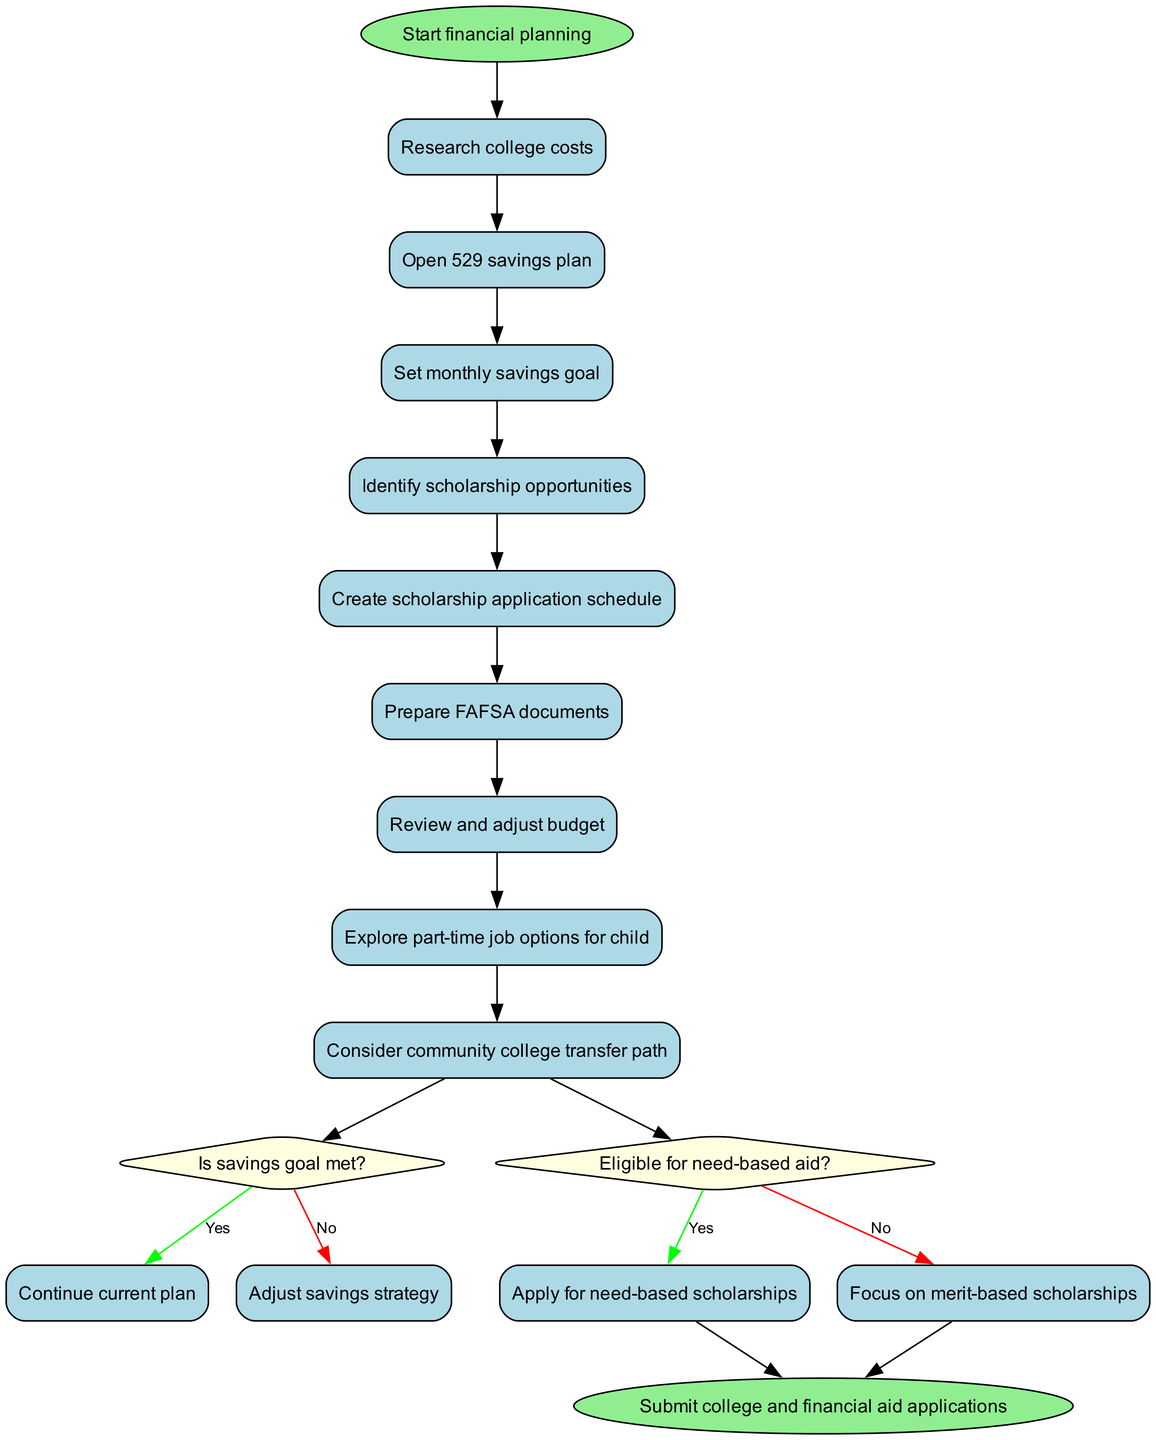What is the first activity in the diagram? The first activity is indicated directly after the initial node. According to the diagram, the first activity is "Research college costs."
Answer: Research college costs How many activities are there in total? To find the total number of activities, we can simply count each one listed in the activities section of the diagram. There are 9 activities.
Answer: 9 What happens if the savings goal is not met? The diagram shows a decision node with the question "Is savings goal met?" If the answer is "No," the flow goes to "Adjust savings strategy."
Answer: Adjust savings strategy What is the final node named? The final node can be identified as the last action in the flow of the diagram, which summarizes the overall goal. It is named "Submit college and financial aid applications."
Answer: Submit college and financial aid applications What decision comes after preparing FAFSA documents? The activity "Prepare FAFSA documents" is directly connected to the decision node asking "Eligible for need-based aid?" Thus, this decision follows after preparing FAFSA documents.
Answer: Eligible for need-based aid? If the answer to the need-based aid question is "Yes," what is the next action? Following the decision about eligibility for need-based aid, if the answer is "Yes," the flow indicates to "Apply for need-based scholarships." This ties into the flow of actions regarding scholarship opportunities.
Answer: Apply for need-based scholarships Which activity is related to providing financial support during high school? The activity "Explore part-time job options for child" is related to finding ways to provide financial support during high school. It shows a proactive approach to managing finances.
Answer: Explore part-time job options for child Is there an option to consider a community college transfer? The diagram includes an activity titled "Consider community college transfer path." Thus, it confirms there is indeed an option to explore this pathway.
Answer: Yes 